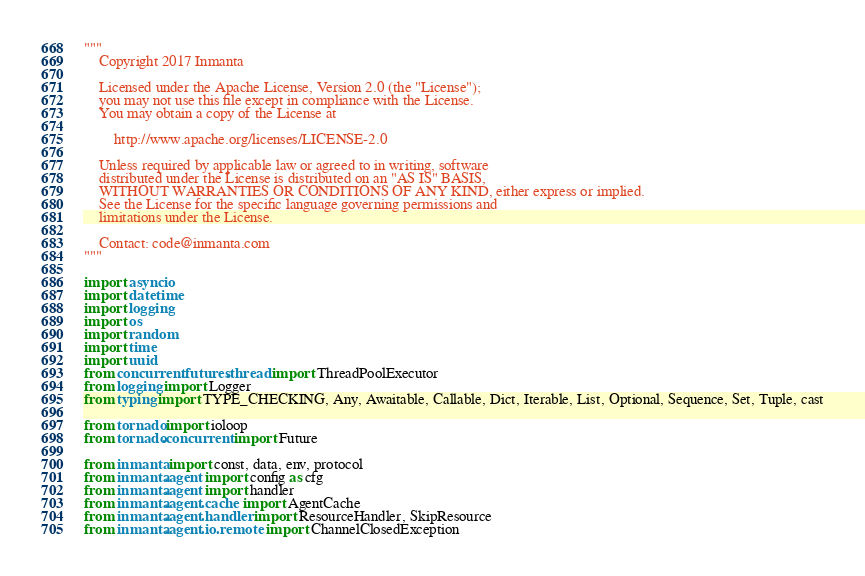Convert code to text. <code><loc_0><loc_0><loc_500><loc_500><_Python_>"""
    Copyright 2017 Inmanta

    Licensed under the Apache License, Version 2.0 (the "License");
    you may not use this file except in compliance with the License.
    You may obtain a copy of the License at

        http://www.apache.org/licenses/LICENSE-2.0

    Unless required by applicable law or agreed to in writing, software
    distributed under the License is distributed on an "AS IS" BASIS,
    WITHOUT WARRANTIES OR CONDITIONS OF ANY KIND, either express or implied.
    See the License for the specific language governing permissions and
    limitations under the License.

    Contact: code@inmanta.com
"""

import asyncio
import datetime
import logging
import os
import random
import time
import uuid
from concurrent.futures.thread import ThreadPoolExecutor
from logging import Logger
from typing import TYPE_CHECKING, Any, Awaitable, Callable, Dict, Iterable, List, Optional, Sequence, Set, Tuple, cast

from tornado import ioloop
from tornado.concurrent import Future

from inmanta import const, data, env, protocol
from inmanta.agent import config as cfg
from inmanta.agent import handler
from inmanta.agent.cache import AgentCache
from inmanta.agent.handler import ResourceHandler, SkipResource
from inmanta.agent.io.remote import ChannelClosedException</code> 